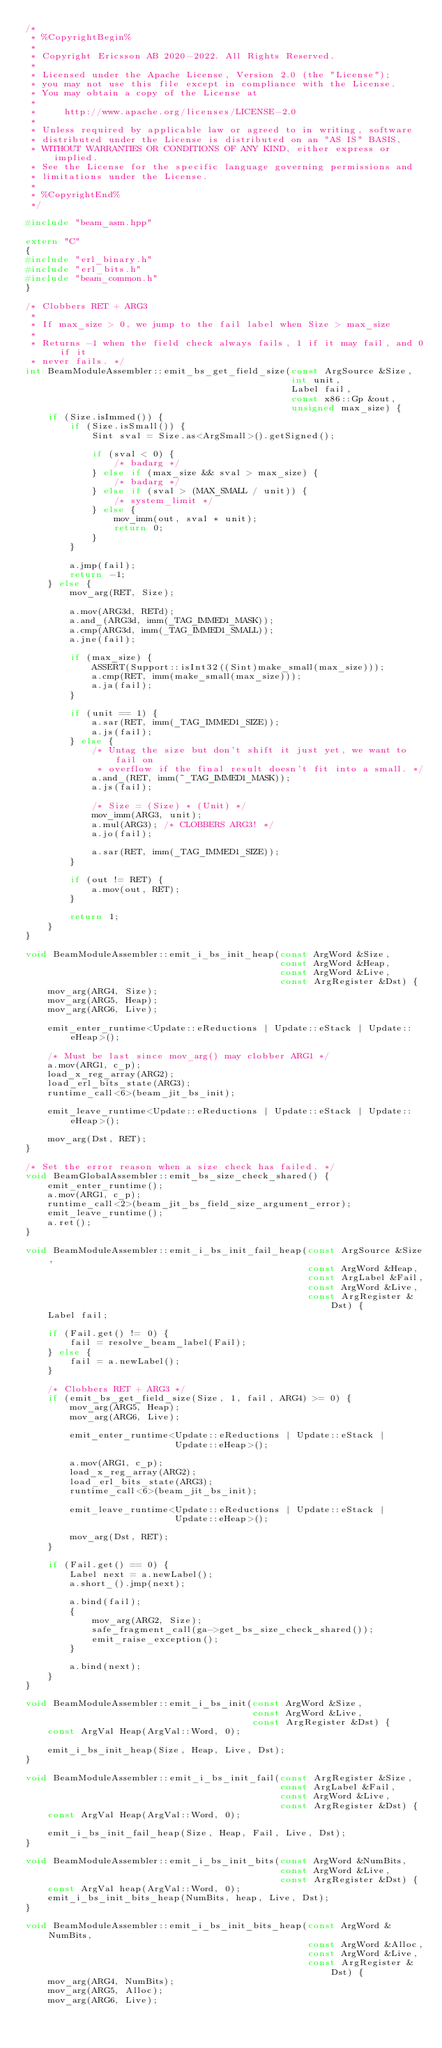Convert code to text. <code><loc_0><loc_0><loc_500><loc_500><_C++_>/*
 * %CopyrightBegin%
 *
 * Copyright Ericsson AB 2020-2022. All Rights Reserved.
 *
 * Licensed under the Apache License, Version 2.0 (the "License");
 * you may not use this file except in compliance with the License.
 * You may obtain a copy of the License at
 *
 *     http://www.apache.org/licenses/LICENSE-2.0
 *
 * Unless required by applicable law or agreed to in writing, software
 * distributed under the License is distributed on an "AS IS" BASIS,
 * WITHOUT WARRANTIES OR CONDITIONS OF ANY KIND, either express or implied.
 * See the License for the specific language governing permissions and
 * limitations under the License.
 *
 * %CopyrightEnd%
 */

#include "beam_asm.hpp"

extern "C"
{
#include "erl_binary.h"
#include "erl_bits.h"
#include "beam_common.h"
}

/* Clobbers RET + ARG3
 *
 * If max_size > 0, we jump to the fail label when Size > max_size
 *
 * Returns -1 when the field check always fails, 1 if it may fail, and 0 if it
 * never fails. */
int BeamModuleAssembler::emit_bs_get_field_size(const ArgSource &Size,
                                                int unit,
                                                Label fail,
                                                const x86::Gp &out,
                                                unsigned max_size) {
    if (Size.isImmed()) {
        if (Size.isSmall()) {
            Sint sval = Size.as<ArgSmall>().getSigned();

            if (sval < 0) {
                /* badarg */
            } else if (max_size && sval > max_size) {
                /* badarg */
            } else if (sval > (MAX_SMALL / unit)) {
                /* system_limit */
            } else {
                mov_imm(out, sval * unit);
                return 0;
            }
        }

        a.jmp(fail);
        return -1;
    } else {
        mov_arg(RET, Size);

        a.mov(ARG3d, RETd);
        a.and_(ARG3d, imm(_TAG_IMMED1_MASK));
        a.cmp(ARG3d, imm(_TAG_IMMED1_SMALL));
        a.jne(fail);

        if (max_size) {
            ASSERT(Support::isInt32((Sint)make_small(max_size)));
            a.cmp(RET, imm(make_small(max_size)));
            a.ja(fail);
        }

        if (unit == 1) {
            a.sar(RET, imm(_TAG_IMMED1_SIZE));
            a.js(fail);
        } else {
            /* Untag the size but don't shift it just yet, we want to fail on
             * overflow if the final result doesn't fit into a small. */
            a.and_(RET, imm(~_TAG_IMMED1_MASK));
            a.js(fail);

            /* Size = (Size) * (Unit) */
            mov_imm(ARG3, unit);
            a.mul(ARG3); /* CLOBBERS ARG3! */
            a.jo(fail);

            a.sar(RET, imm(_TAG_IMMED1_SIZE));
        }

        if (out != RET) {
            a.mov(out, RET);
        }

        return 1;
    }
}

void BeamModuleAssembler::emit_i_bs_init_heap(const ArgWord &Size,
                                              const ArgWord &Heap,
                                              const ArgWord &Live,
                                              const ArgRegister &Dst) {
    mov_arg(ARG4, Size);
    mov_arg(ARG5, Heap);
    mov_arg(ARG6, Live);

    emit_enter_runtime<Update::eReductions | Update::eStack | Update::eHeap>();

    /* Must be last since mov_arg() may clobber ARG1 */
    a.mov(ARG1, c_p);
    load_x_reg_array(ARG2);
    load_erl_bits_state(ARG3);
    runtime_call<6>(beam_jit_bs_init);

    emit_leave_runtime<Update::eReductions | Update::eStack | Update::eHeap>();

    mov_arg(Dst, RET);
}

/* Set the error reason when a size check has failed. */
void BeamGlobalAssembler::emit_bs_size_check_shared() {
    emit_enter_runtime();
    a.mov(ARG1, c_p);
    runtime_call<2>(beam_jit_bs_field_size_argument_error);
    emit_leave_runtime();
    a.ret();
}

void BeamModuleAssembler::emit_i_bs_init_fail_heap(const ArgSource &Size,
                                                   const ArgWord &Heap,
                                                   const ArgLabel &Fail,
                                                   const ArgWord &Live,
                                                   const ArgRegister &Dst) {
    Label fail;

    if (Fail.get() != 0) {
        fail = resolve_beam_label(Fail);
    } else {
        fail = a.newLabel();
    }

    /* Clobbers RET + ARG3 */
    if (emit_bs_get_field_size(Size, 1, fail, ARG4) >= 0) {
        mov_arg(ARG5, Heap);
        mov_arg(ARG6, Live);

        emit_enter_runtime<Update::eReductions | Update::eStack |
                           Update::eHeap>();

        a.mov(ARG1, c_p);
        load_x_reg_array(ARG2);
        load_erl_bits_state(ARG3);
        runtime_call<6>(beam_jit_bs_init);

        emit_leave_runtime<Update::eReductions | Update::eStack |
                           Update::eHeap>();

        mov_arg(Dst, RET);
    }

    if (Fail.get() == 0) {
        Label next = a.newLabel();
        a.short_().jmp(next);

        a.bind(fail);
        {
            mov_arg(ARG2, Size);
            safe_fragment_call(ga->get_bs_size_check_shared());
            emit_raise_exception();
        }

        a.bind(next);
    }
}

void BeamModuleAssembler::emit_i_bs_init(const ArgWord &Size,
                                         const ArgWord &Live,
                                         const ArgRegister &Dst) {
    const ArgVal Heap(ArgVal::Word, 0);

    emit_i_bs_init_heap(Size, Heap, Live, Dst);
}

void BeamModuleAssembler::emit_i_bs_init_fail(const ArgRegister &Size,
                                              const ArgLabel &Fail,
                                              const ArgWord &Live,
                                              const ArgRegister &Dst) {
    const ArgVal Heap(ArgVal::Word, 0);

    emit_i_bs_init_fail_heap(Size, Heap, Fail, Live, Dst);
}

void BeamModuleAssembler::emit_i_bs_init_bits(const ArgWord &NumBits,
                                              const ArgWord &Live,
                                              const ArgRegister &Dst) {
    const ArgVal heap(ArgVal::Word, 0);
    emit_i_bs_init_bits_heap(NumBits, heap, Live, Dst);
}

void BeamModuleAssembler::emit_i_bs_init_bits_heap(const ArgWord &NumBits,
                                                   const ArgWord &Alloc,
                                                   const ArgWord &Live,
                                                   const ArgRegister &Dst) {
    mov_arg(ARG4, NumBits);
    mov_arg(ARG5, Alloc);
    mov_arg(ARG6, Live);
</code> 